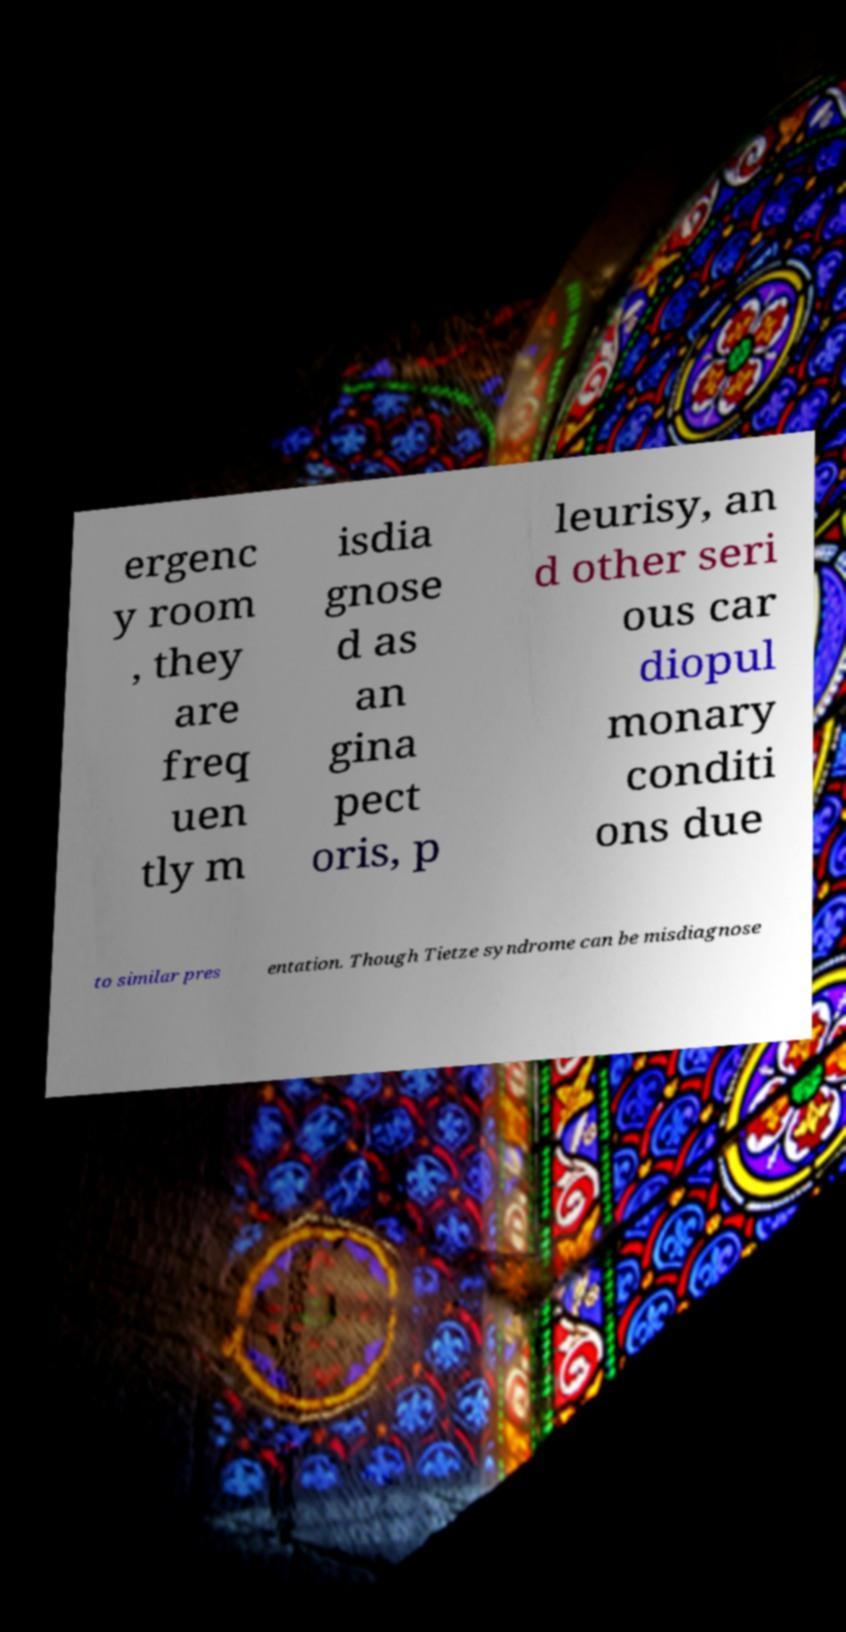Can you accurately transcribe the text from the provided image for me? ergenc y room , they are freq uen tly m isdia gnose d as an gina pect oris, p leurisy, an d other seri ous car diopul monary conditi ons due to similar pres entation. Though Tietze syndrome can be misdiagnose 